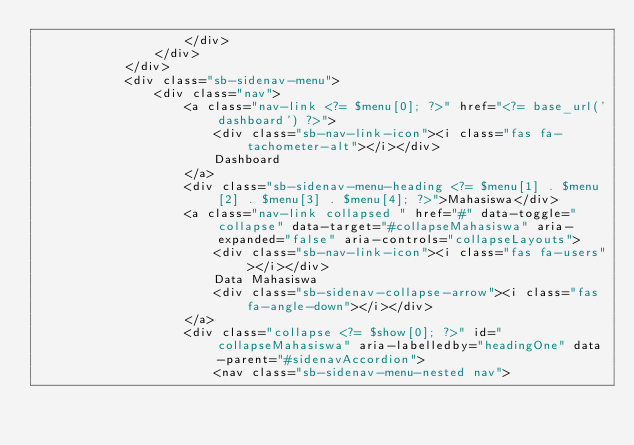Convert code to text. <code><loc_0><loc_0><loc_500><loc_500><_PHP_>                    </div>
                </div>
            </div>
            <div class="sb-sidenav-menu">
                <div class="nav">
                    <a class="nav-link <?= $menu[0]; ?>" href="<?= base_url('dashboard') ?>">
                        <div class="sb-nav-link-icon"><i class="fas fa-tachometer-alt"></i></div>
                        Dashboard
                    </a>
                    <div class="sb-sidenav-menu-heading <?= $menu[1] . $menu[2] . $menu[3] . $menu[4]; ?>">Mahasiswa</div>
                    <a class="nav-link collapsed " href="#" data-toggle="collapse" data-target="#collapseMahasiswa" aria-expanded="false" aria-controls="collapseLayouts">
                        <div class="sb-nav-link-icon"><i class="fas fa-users"></i></div>
                        Data Mahasiswa
                        <div class="sb-sidenav-collapse-arrow"><i class="fas fa-angle-down"></i></div>
                    </a>
                    <div class="collapse <?= $show[0]; ?>" id="collapseMahasiswa" aria-labelledby="headingOne" data-parent="#sidenavAccordion">
                        <nav class="sb-sidenav-menu-nested nav"></code> 